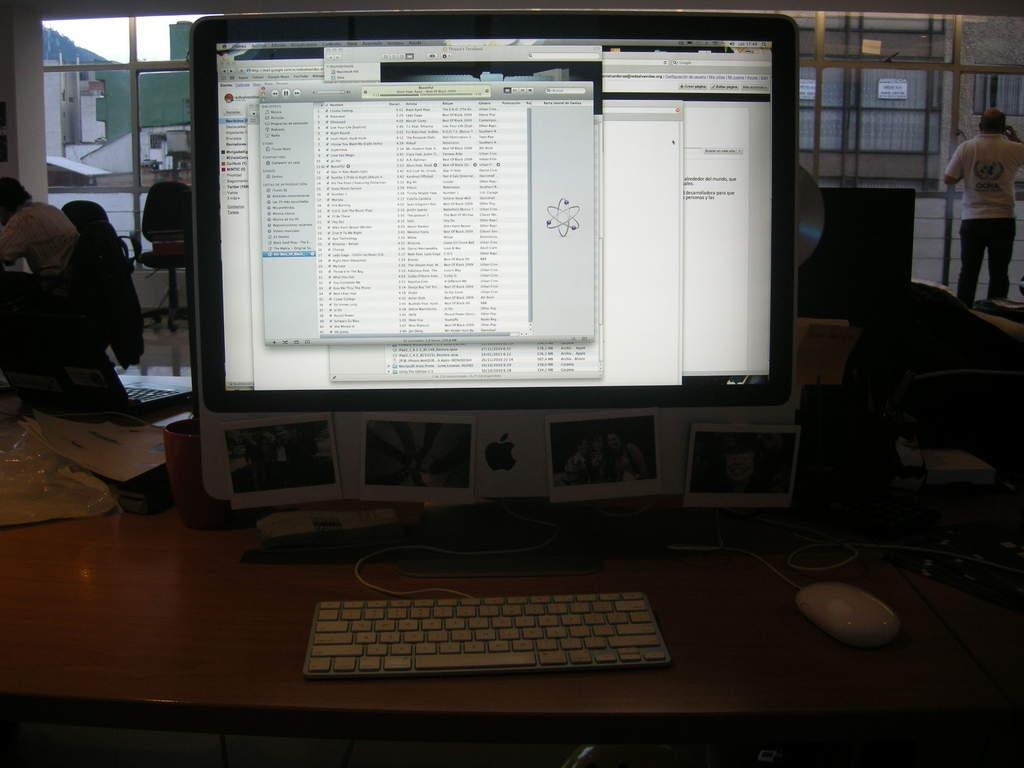<image>
Relay a brief, clear account of the picture shown. a mac computer that has the screen open to an itunes tab 